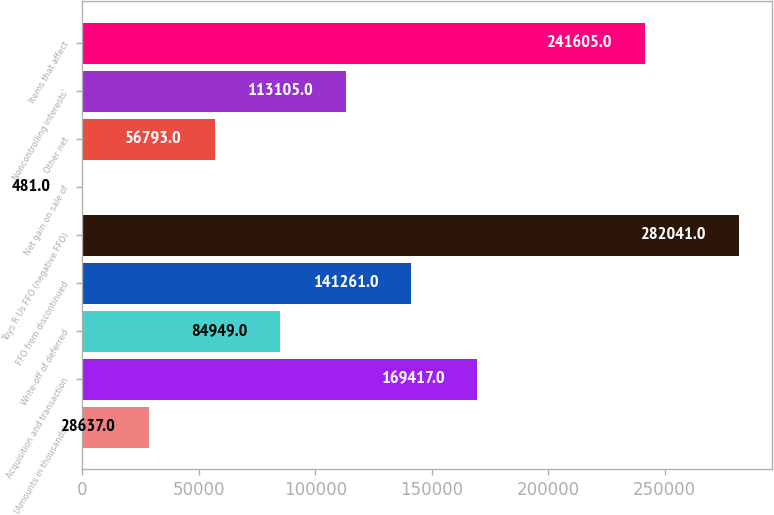<chart> <loc_0><loc_0><loc_500><loc_500><bar_chart><fcel>(Amounts in thousands)<fcel>Acquisition and transaction<fcel>Write-off of deferred<fcel>FFO from discontinued<fcel>Toys R Us FFO (negative FFO)<fcel>Net gain on sale of<fcel>Other net<fcel>Noncontrolling interests'<fcel>Items that affect<nl><fcel>28637<fcel>169417<fcel>84949<fcel>141261<fcel>282041<fcel>481<fcel>56793<fcel>113105<fcel>241605<nl></chart> 